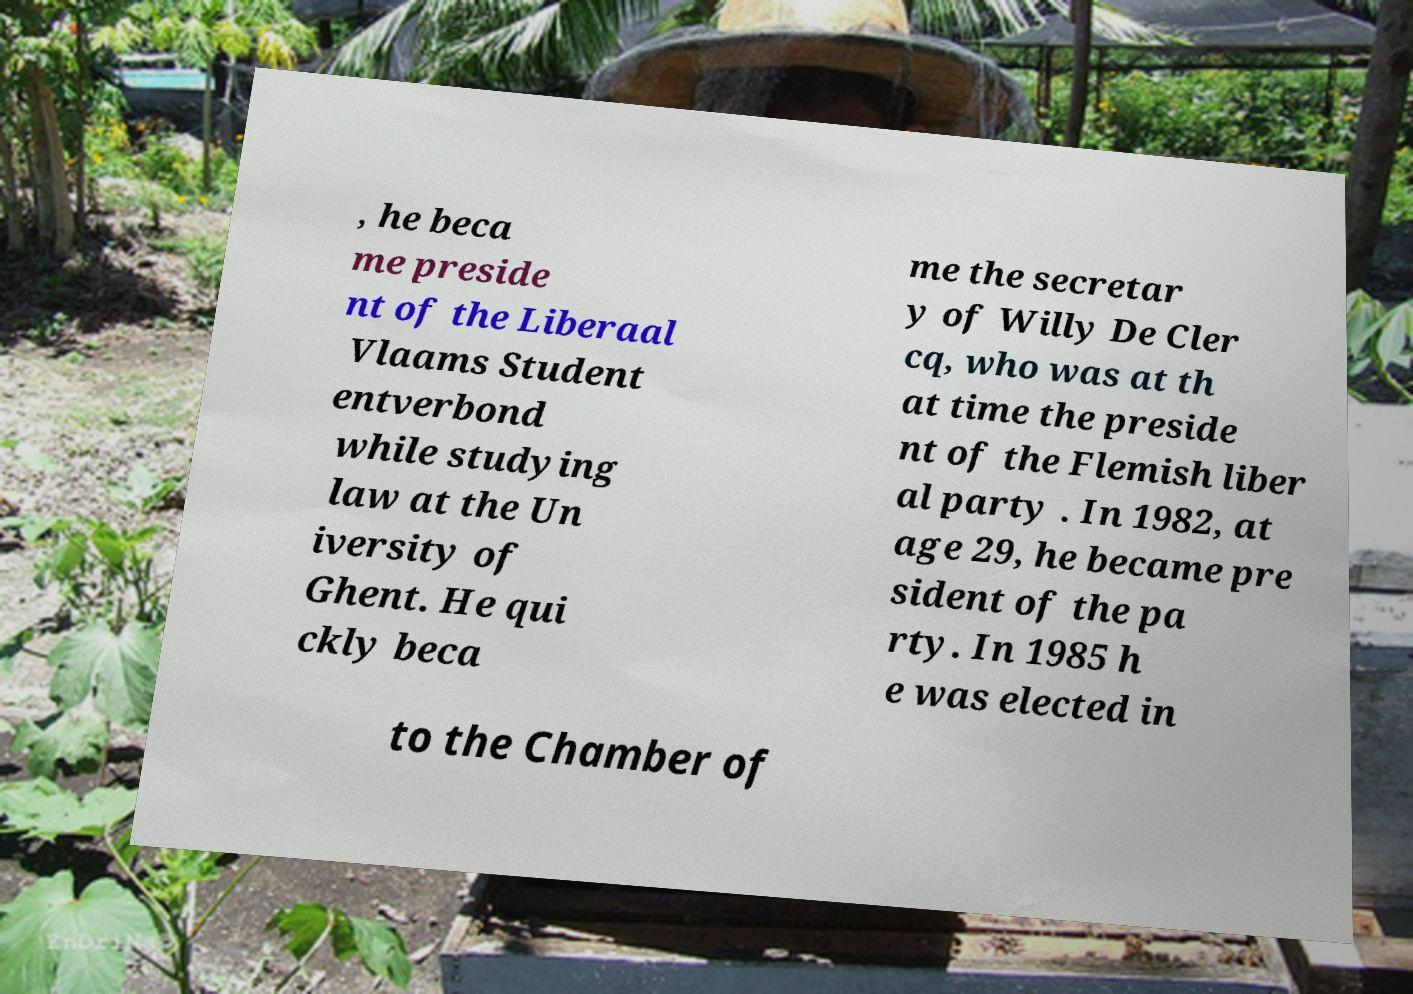What messages or text are displayed in this image? I need them in a readable, typed format. , he beca me preside nt of the Liberaal Vlaams Student entverbond while studying law at the Un iversity of Ghent. He qui ckly beca me the secretar y of Willy De Cler cq, who was at th at time the preside nt of the Flemish liber al party . In 1982, at age 29, he became pre sident of the pa rty. In 1985 h e was elected in to the Chamber of 